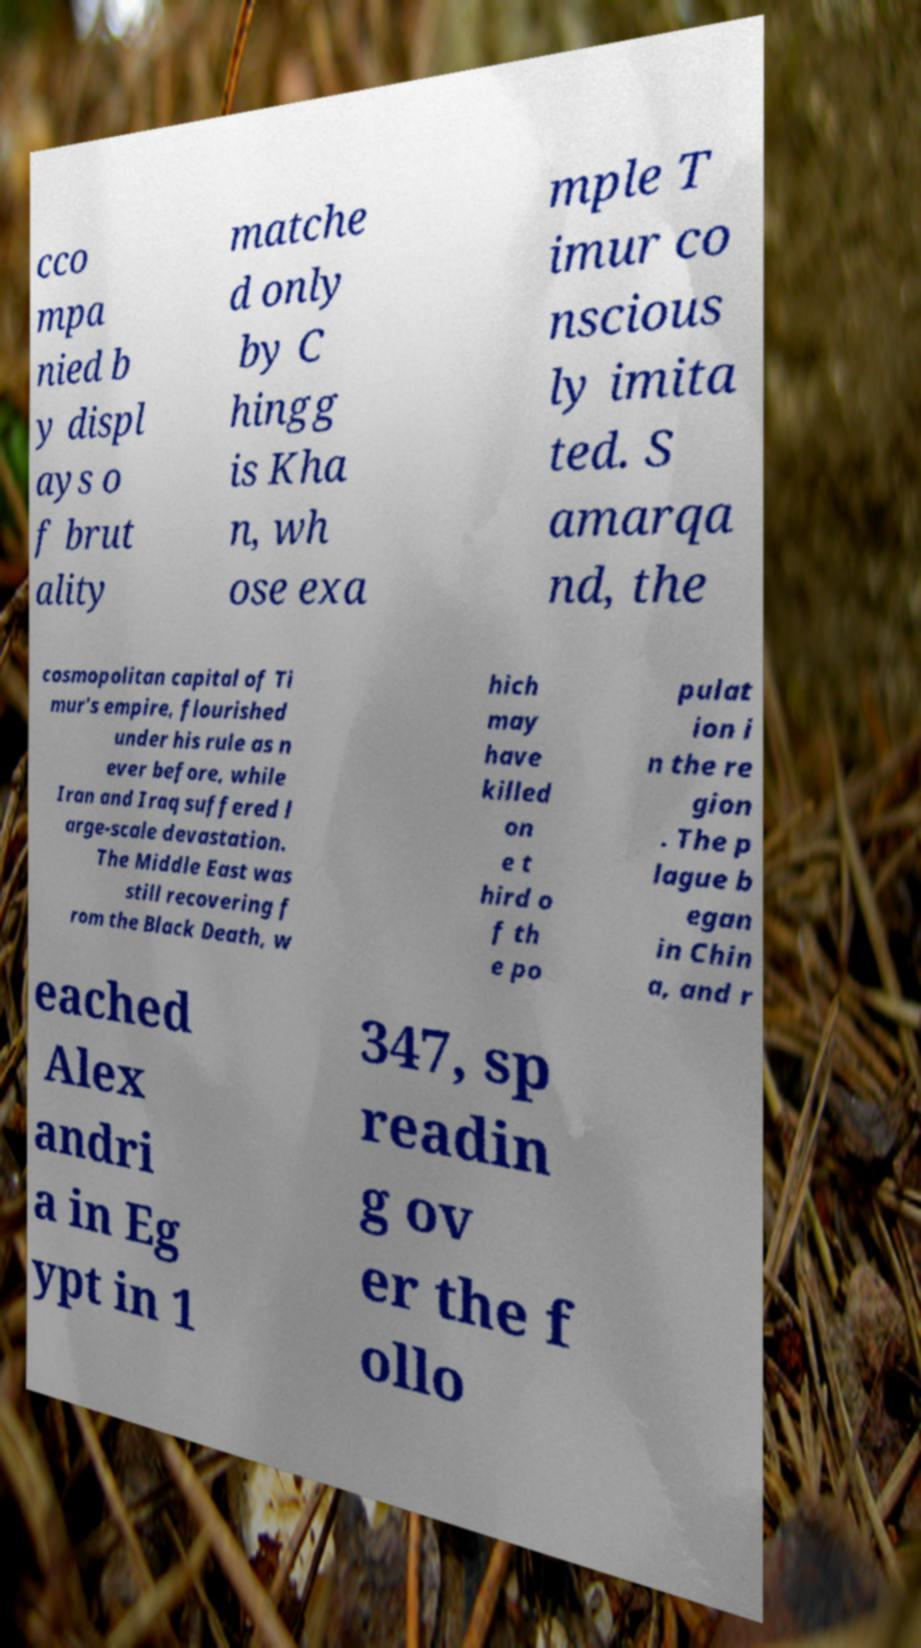Could you extract and type out the text from this image? cco mpa nied b y displ ays o f brut ality matche d only by C hingg is Kha n, wh ose exa mple T imur co nscious ly imita ted. S amarqa nd, the cosmopolitan capital of Ti mur's empire, flourished under his rule as n ever before, while Iran and Iraq suffered l arge-scale devastation. The Middle East was still recovering f rom the Black Death, w hich may have killed on e t hird o f th e po pulat ion i n the re gion . The p lague b egan in Chin a, and r eached Alex andri a in Eg ypt in 1 347, sp readin g ov er the f ollo 